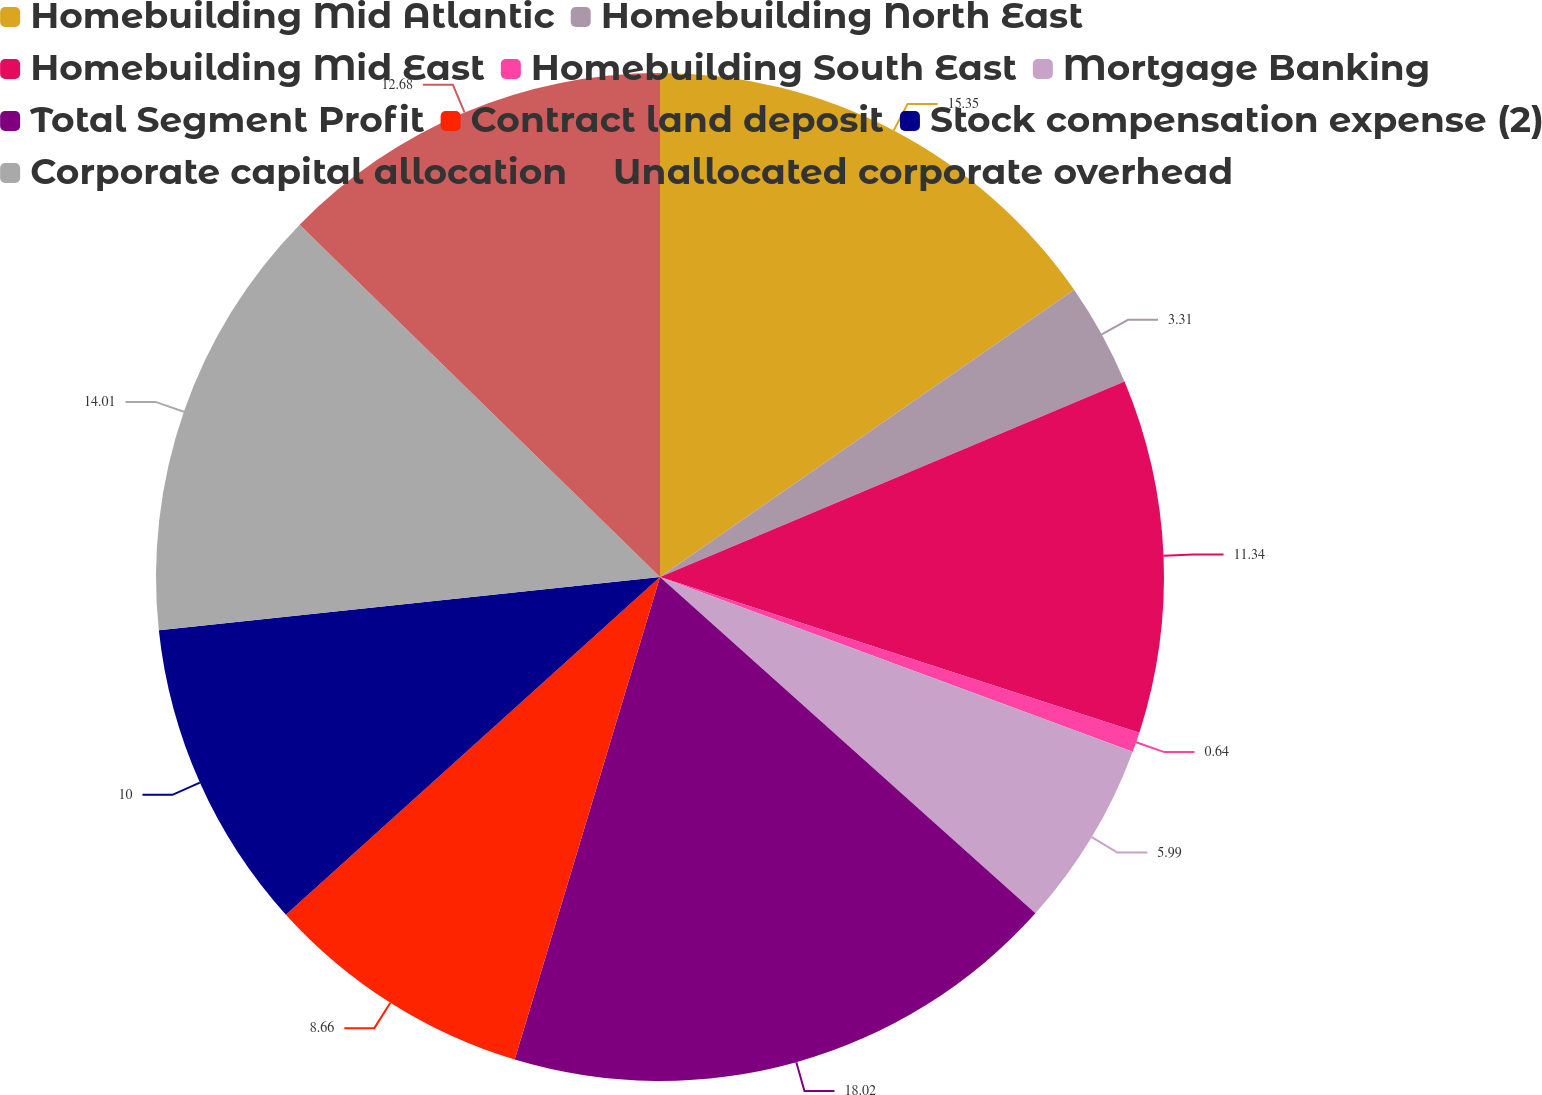Convert chart to OTSL. <chart><loc_0><loc_0><loc_500><loc_500><pie_chart><fcel>Homebuilding Mid Atlantic<fcel>Homebuilding North East<fcel>Homebuilding Mid East<fcel>Homebuilding South East<fcel>Mortgage Banking<fcel>Total Segment Profit<fcel>Contract land deposit<fcel>Stock compensation expense (2)<fcel>Corporate capital allocation<fcel>Unallocated corporate overhead<nl><fcel>15.35%<fcel>3.31%<fcel>11.34%<fcel>0.64%<fcel>5.99%<fcel>18.03%<fcel>8.66%<fcel>10.0%<fcel>14.01%<fcel>12.68%<nl></chart> 